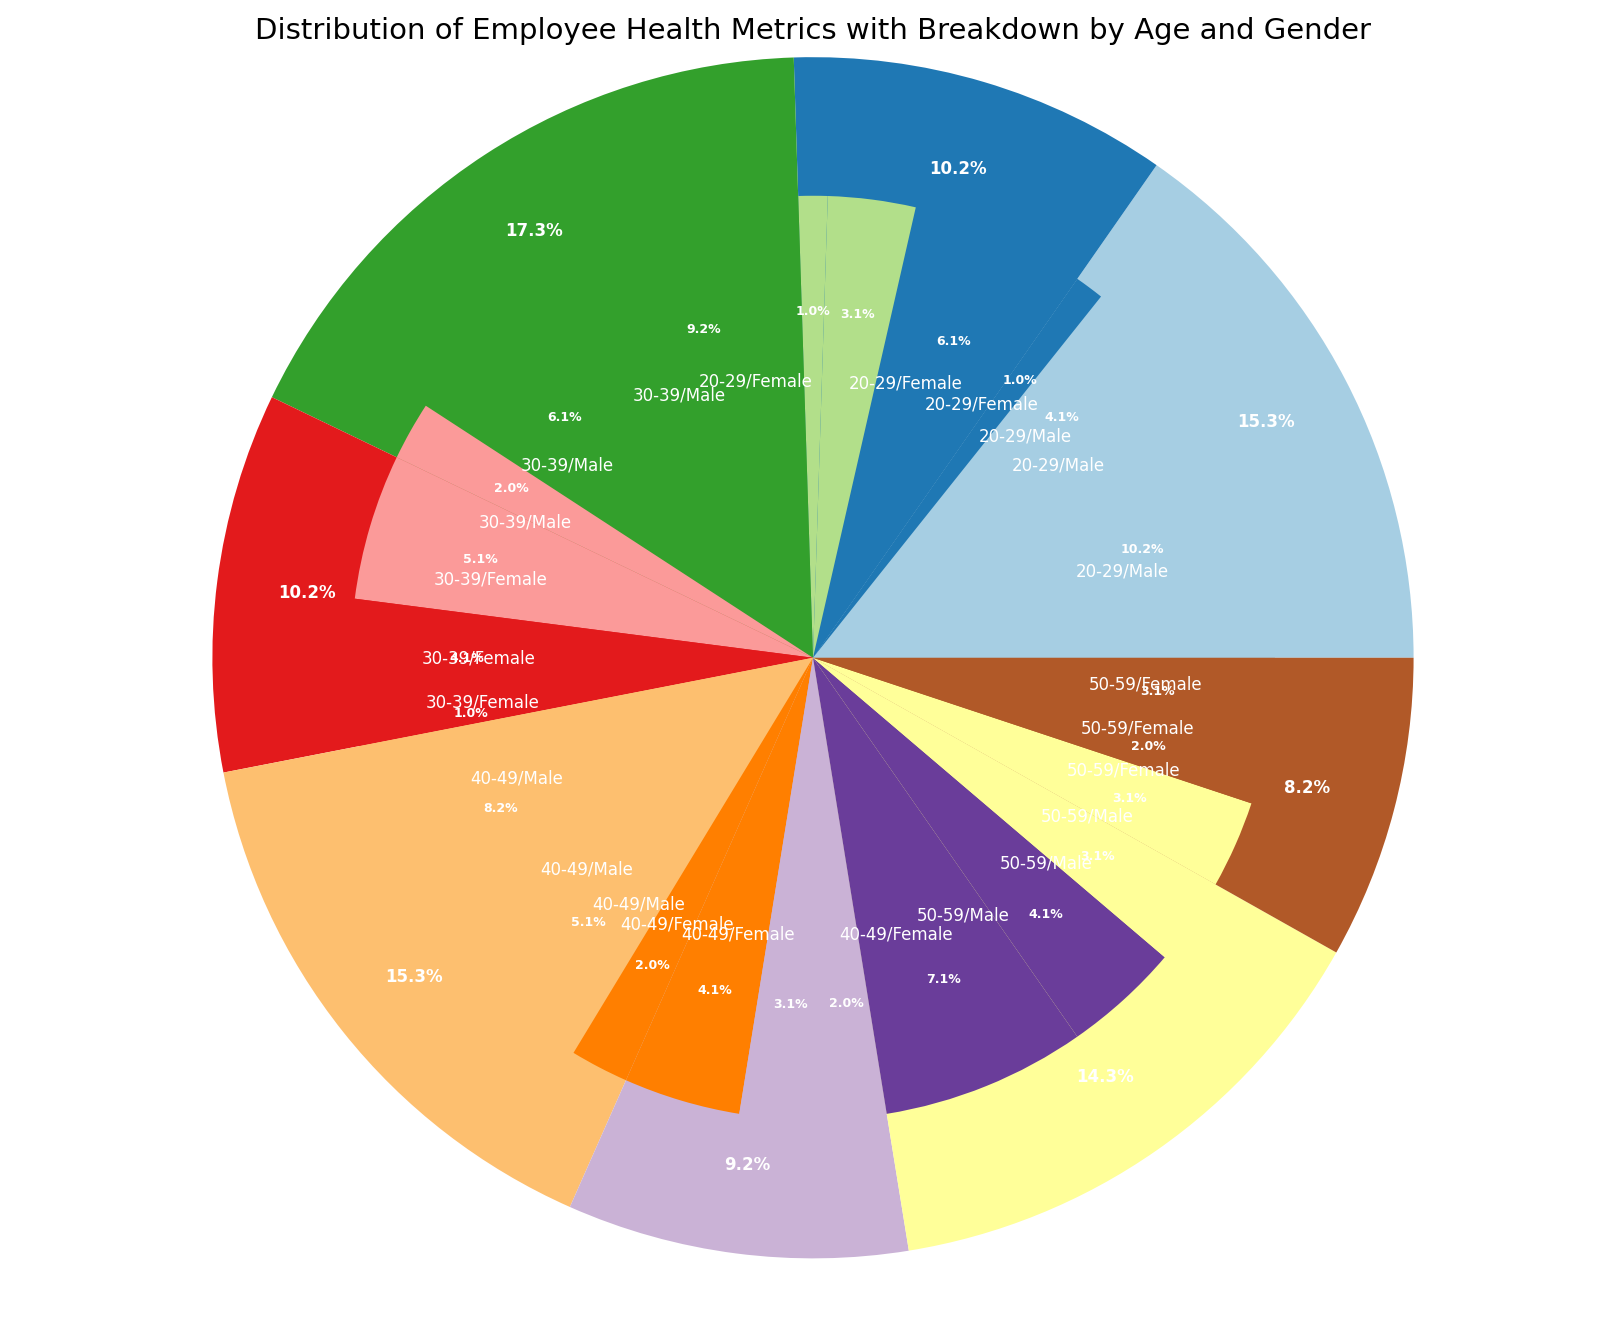Which age group has the highest number of healthy male employees? Look at the pie chart sections labeled for each age group and gender, then identify the segment representing healthy males. The 20-29 age group has the largest segment of healthy male employees.
Answer: 20-29 How many more healthy employees are there in the 30-39 age group compared to the 50-59 age group? Sum the counts of healthy employees for each age group and compare. 30-39 group has (45 males + 25 females) = 70 healthy employees. 50-59 group has (35 males + 15 females) = 50 healthy employees. The difference is 70 - 50.
Answer: 20 What is the percentage of unhealthy female employees in the 40-49 age group? Look at the segment for unhealthy females in the 40-49 age group and check the percentage value displayed on the chart. The unhealthy female segment should display the percentage.
Answer: 10% In which age group is the percentage of moderate male employees greater than the percentage of moderate female employees? Examine the pie chart segments for moderate males and females across each age group. Compare their sizes and percentages. The 50-59 age group shows a larger percentage for moderate males than females.
Answer: 50-59 Between the age groups 30-39 and 40-49, which one has a higher count of unhealthy employees? Sum the counts of unhealthy employees for each age group, comparing the total unhealthy employees. 30-39 has 15 unhealthy employees (10 males + 5 females) while 40-49 has 20 unhealthy employees (10 males + 10 females).
Answer: 40-49 What percentage of female employees are classified as healthy in the 20-29 age group? Identify the segment for healthy females in the 20-29 age group and check the displayed percentage on the pie chart. This should give the percentage value.
Answer: 60% Which gender has a higher representation in the moderate health metric across all age groups? Compare the total counts of moderate male and female employees by looking at the respective segments across all age groups. The cumulative count for males is higher than females.
Answer: Male In the 30-39 age group, what proportion of employees are classified as unhealthy? Summarize the counts of all employees in the 30-39 age group and calculate the proportion of unhealthy employees: (10 males + 5 females = 15 unhealthy) / (115 total). Multiply by 100 to get the percentage.
Answer: 13% Are there any age groups where the count of unhealthy employees is equal between males and females? Check the segments labeled unhealthy in each age group and compare the counts between males and females. The 50-59 age group has the counts equal for unhealthy males and females (15 each).
Answer: Yes, 50-59 